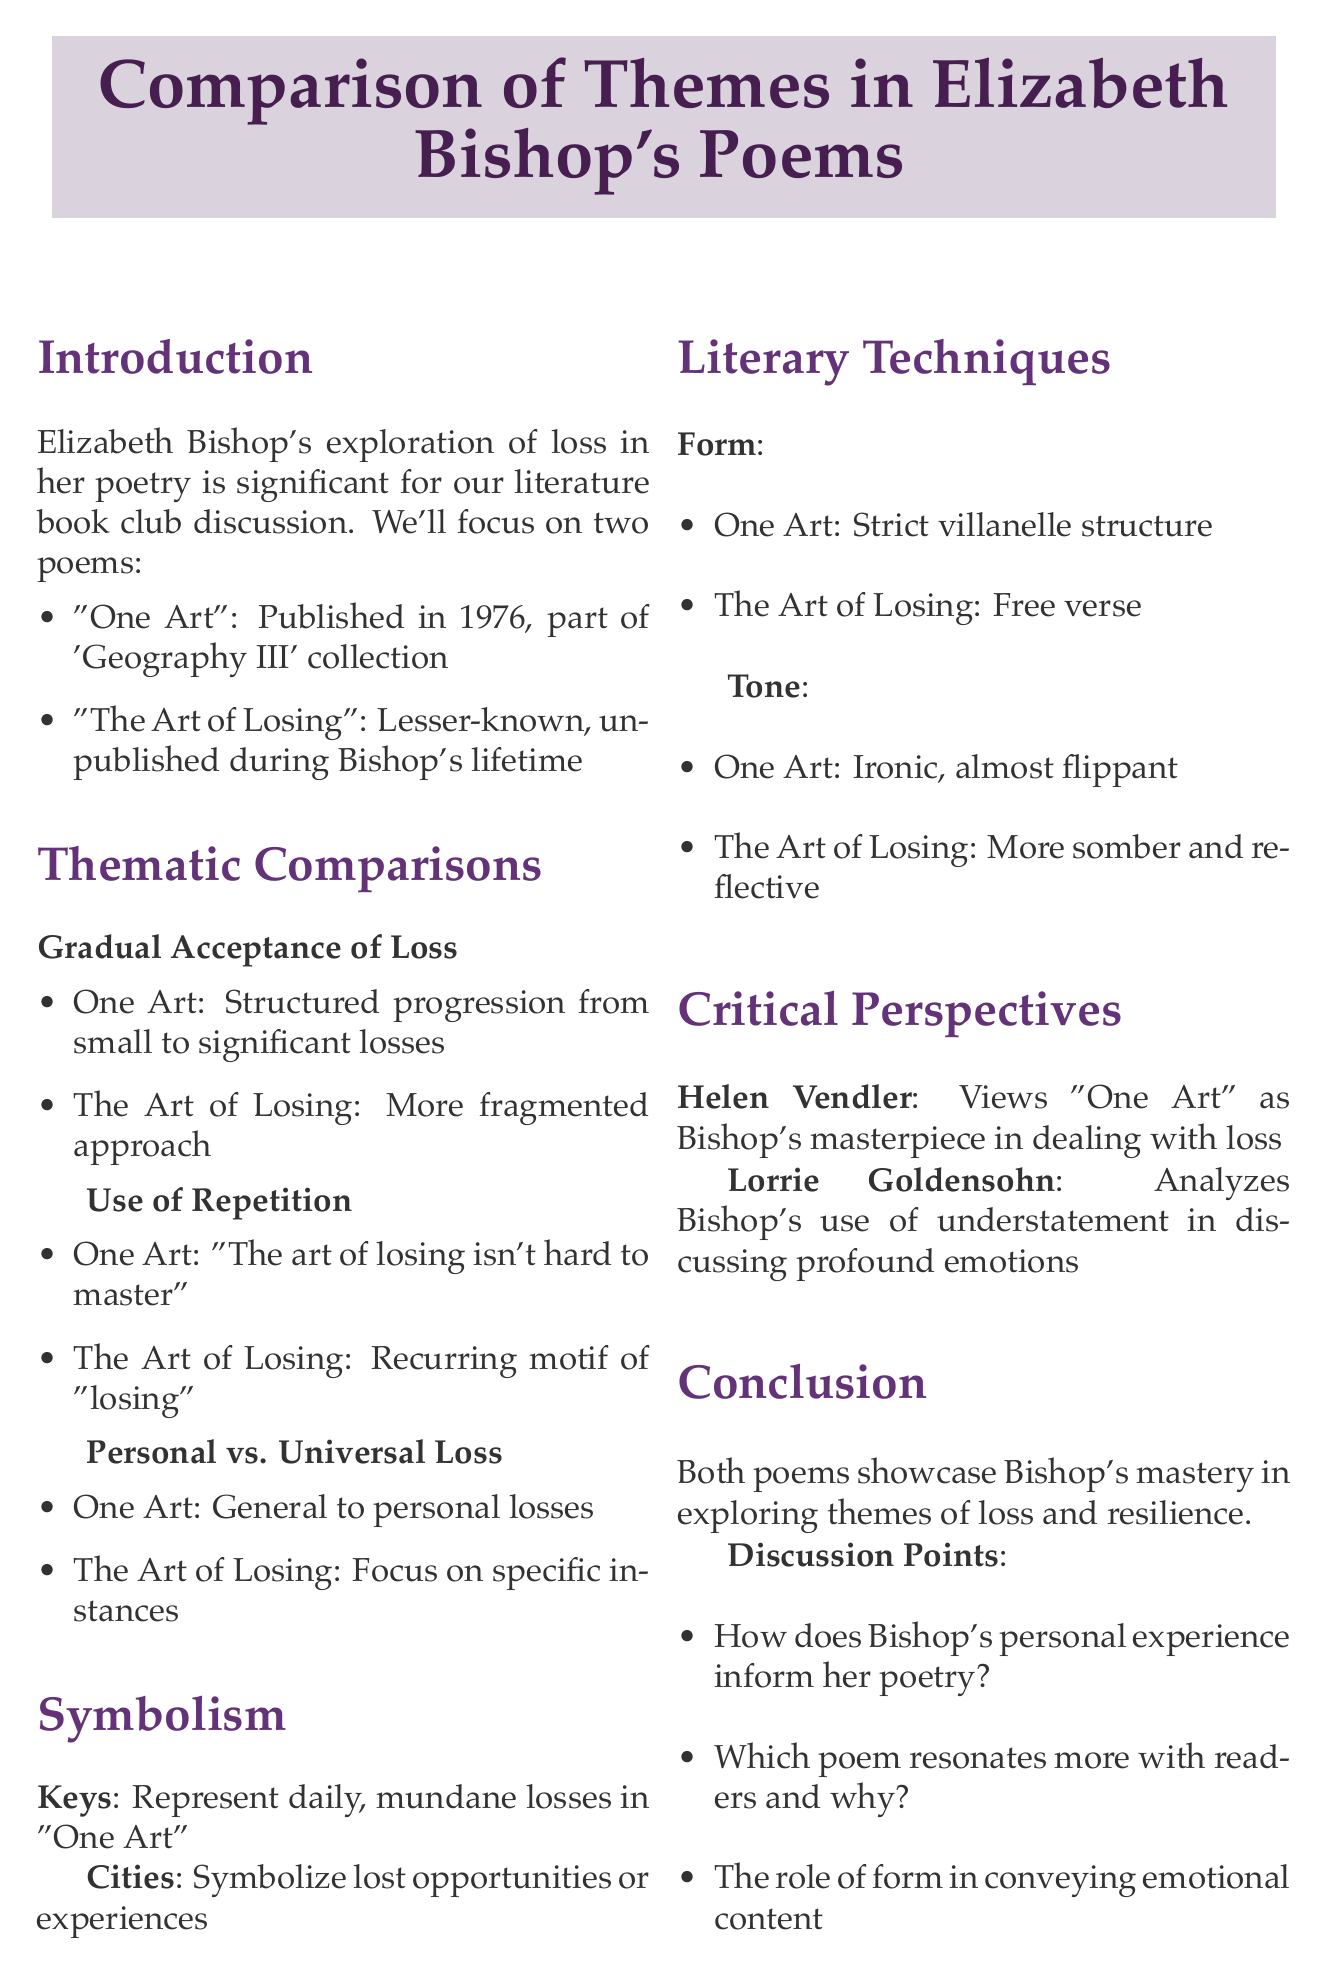What year was "One Art" published? The document states that "One Art" was published in 1976, as part of the 'Geography III' collection.
Answer: 1976 What type of poetic form is "One Art"? The document mentions that "One Art" strictly adheres to the villanelle structure, highlighting its form.
Answer: Villanelle Which critic views "One Art" as Bishop's masterpiece? According to the document, Helen Vendler views "One Art" in this manner.
Answer: Helen Vendler What is the main theme in both poems? The document summarizes that both poems demonstrate Bishop's mastery in exploring themes of loss and resilience.
Answer: Loss and resilience What object symbolizes daily losses in "One Art"? The document indicates that keys represent daily, mundane losses in "One Art."
Answer: Keys Which poem has a more fragmented approach to loss? The document states that "The Art of Losing" employs a more fragmented approach compared to "One Art."
Answer: The Art of Losing What recurring phrase is emphasized in "One Art"? The document specifies that the repeated phrase in "One Art" is "The art of losing isn't hard to master."
Answer: The art of losing isn't hard to master How does the tone differ between the two poems? The document mentions that "One Art" has an ironic tone, while "The Art of Losing" is more somber and reflective.
Answer: Different tones 